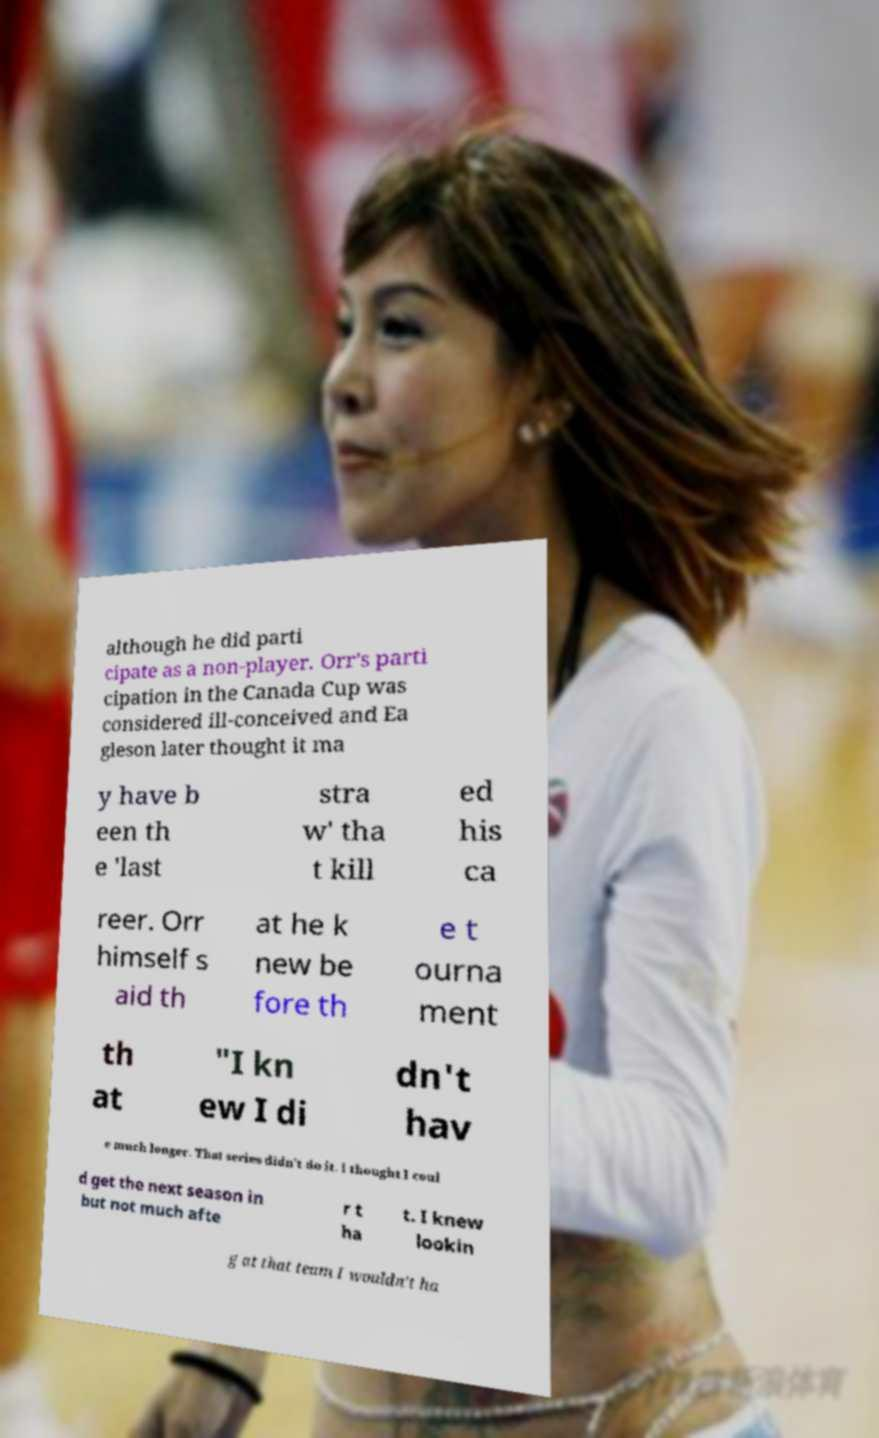Can you read and provide the text displayed in the image?This photo seems to have some interesting text. Can you extract and type it out for me? although he did parti cipate as a non-player. Orr's parti cipation in the Canada Cup was considered ill-conceived and Ea gleson later thought it ma y have b een th e 'last stra w' tha t kill ed his ca reer. Orr himself s aid th at he k new be fore th e t ourna ment th at "I kn ew I di dn't hav e much longer. That series didn't do it. I thought I coul d get the next season in but not much afte r t ha t. I knew lookin g at that team I wouldn't ha 